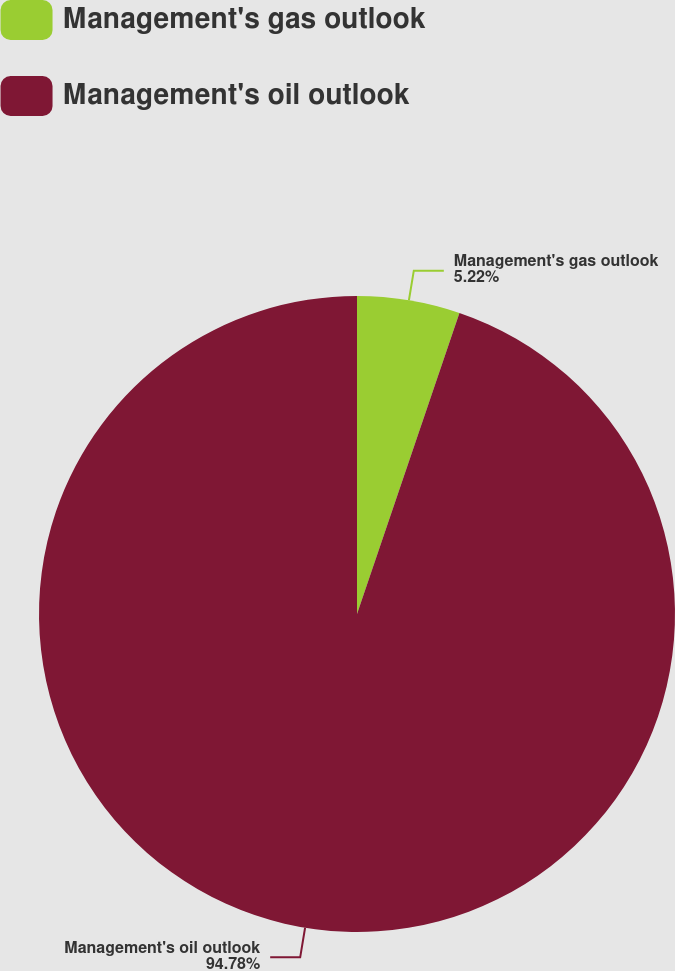Convert chart to OTSL. <chart><loc_0><loc_0><loc_500><loc_500><pie_chart><fcel>Management's gas outlook<fcel>Management's oil outlook<nl><fcel>5.22%<fcel>94.78%<nl></chart> 